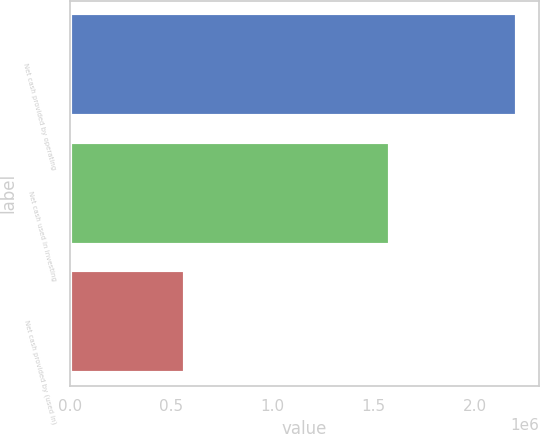Convert chart to OTSL. <chart><loc_0><loc_0><loc_500><loc_500><bar_chart><fcel>Net cash provided by operating<fcel>Net cash used in investing<fcel>Net cash provided by (used in)<nl><fcel>2.20641e+06<fcel>1.58059e+06<fcel>568778<nl></chart> 